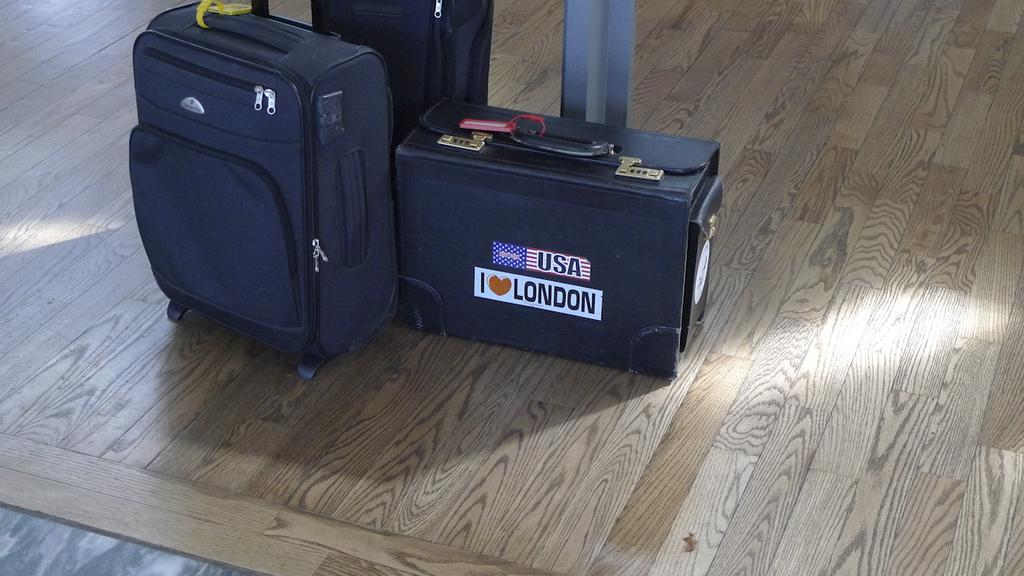What is present in the image? There is baggage in the image. Can you describe the baggage in more detail? Unfortunately, the facts provided do not give any additional details about the baggage. What might the purpose of the baggage be in the image? The purpose of the baggage cannot be determined from the given facts, but it could be related to travel or storage. What is the opinion of the coal on the organization in the image? There is no coal or organization present in the image, so it is not possible to answer that question. 